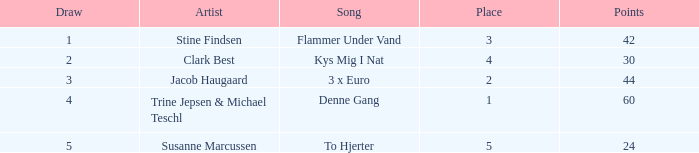What is the least draw when the artist is stine findsen and the points are more than 42? None. 